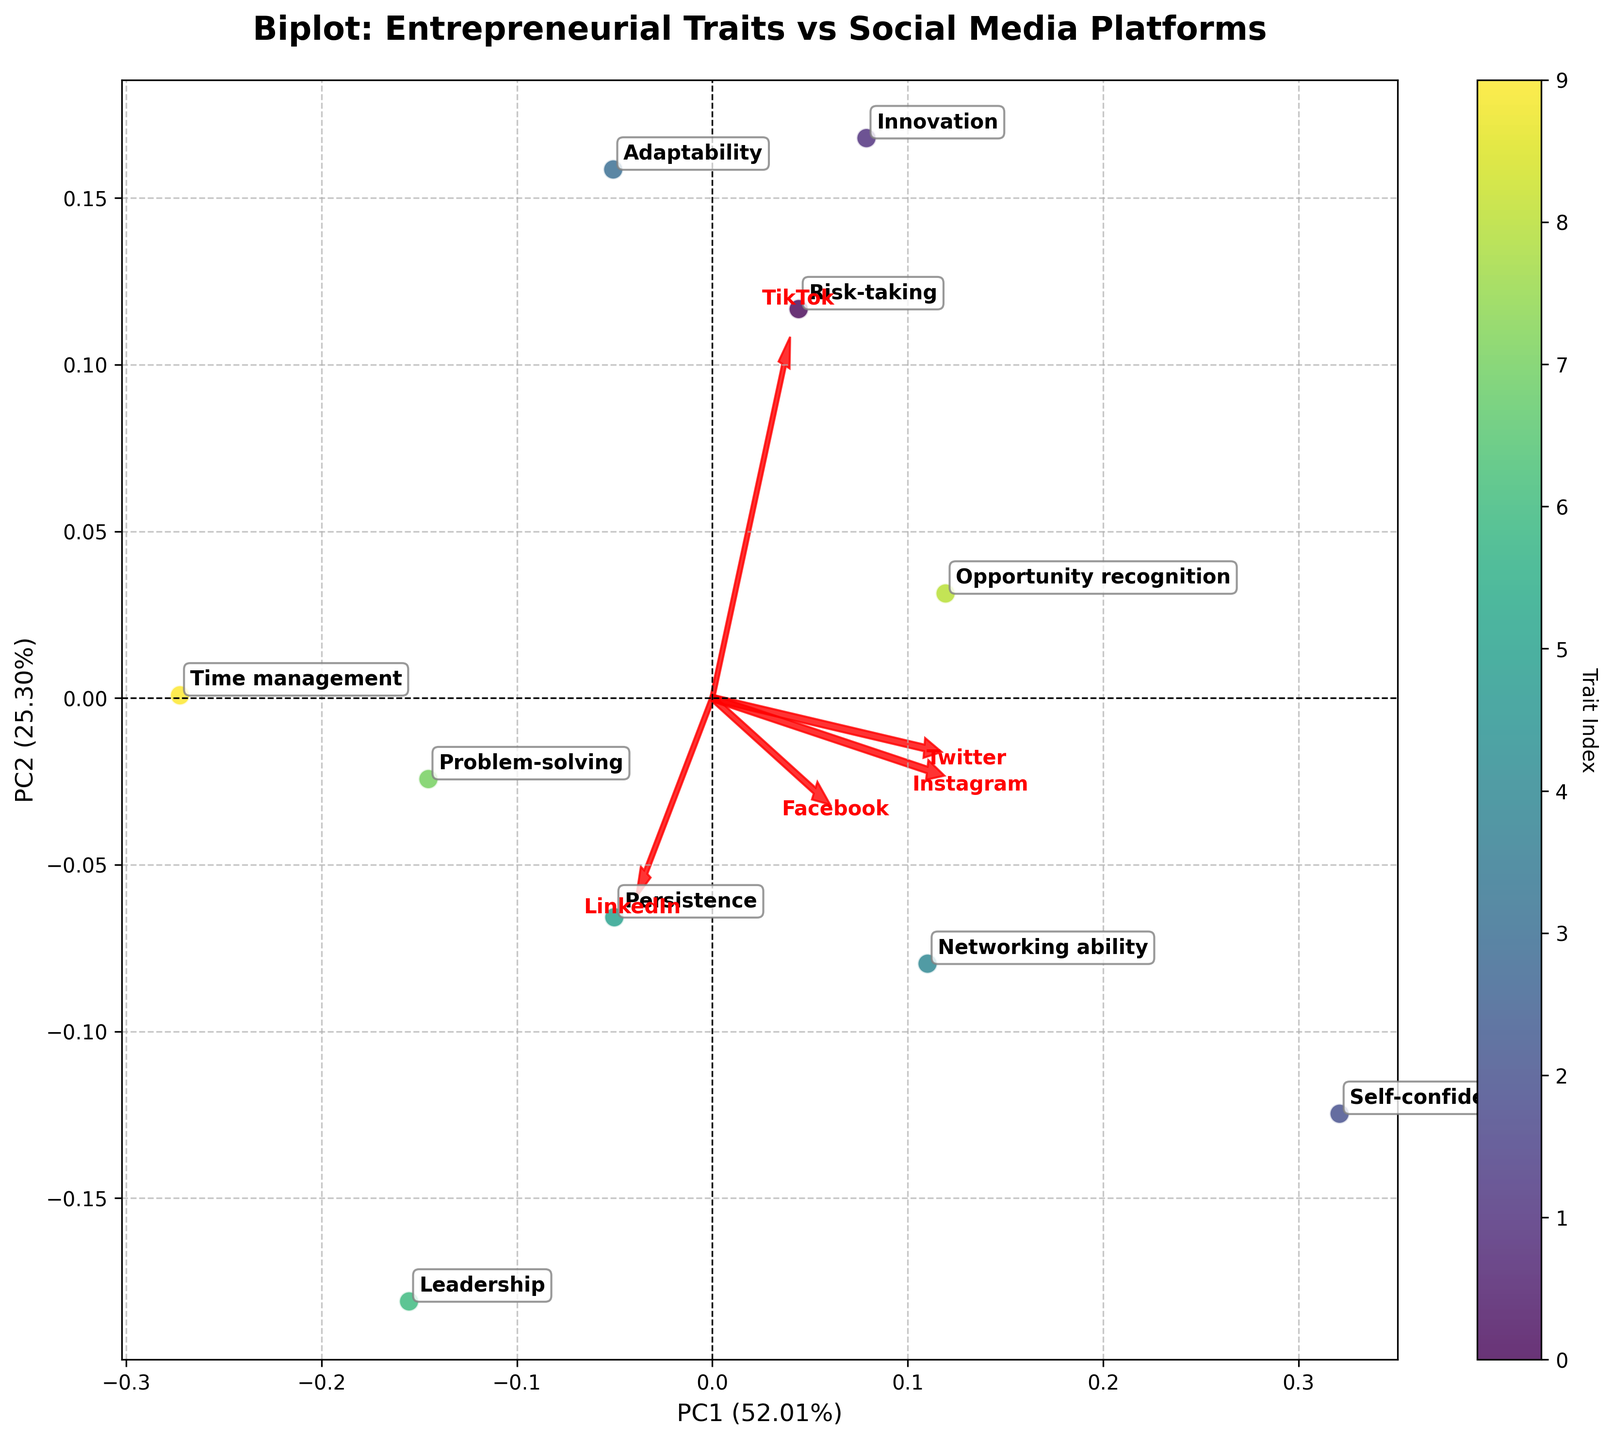What is the title of the figure? The title of the figure is located at the top center and reads "Biplot: Entrepreneurial Traits vs Social Media Platforms".
Answer: Biplot: Entrepreneurial Traits vs Social Media Platforms How many social media platforms are represented by loadings in the plot? Each loading corresponds to a social media platform. By counting the red arrows (loadings) in the figure, we see that there are five.
Answer: Five Which trait scores highest on PC1? By checking the PC1 axis (horizontal axis) and looking for the trait label farthest to the right, we see that "Self-confidence" is the furthest from the origin on the positive side.
Answer: Self-confidence Which social media platform is associated with the highest loadings on both PC1 and PC2? By looking at the arrows' lengths and orientations for loadings, the "LinkedIn" arrow extends farthest in both the PC1 and PC2 directions compared to the others.
Answer: LinkedIn What percentage of variance is explained by PC1? The percentage of variance explained by PC1 is given in the xlabel, where it is noted as 49%.
Answer: 49% Which trait is closest to the origin of the plot? The trait closest to the origin (0,0) of the plot appears to be "Time management" as it is very near the center.
Answer: Time management How do Innovation and Problem-solving traits compare on PC1? Checking the positions on the PC1 axis, Innovation is farther right (positive) than Problem-solving, indicating a higher score on PC1.
Answer: Innovation is higher on PC1 Which trait has a marked outlier position on PC2 compared to others? By examining the PC2 axis (vertical axis), "Self-confidence" stands out far above the other traits indicating its significantly higher score on PC2.
Answer: Self-confidence What is the trait index color bar used for? The color bar represents the trait index, assigning each trait a different color to distinguish them in the scatter plot.
Answer: Distinguish traits by color Which platform has the lowest loading on PC2? By examining the end point of each arrow along the PC2 axis, "Twitter" has the lowest (most negative) loading on PC2.
Answer: Twitter 